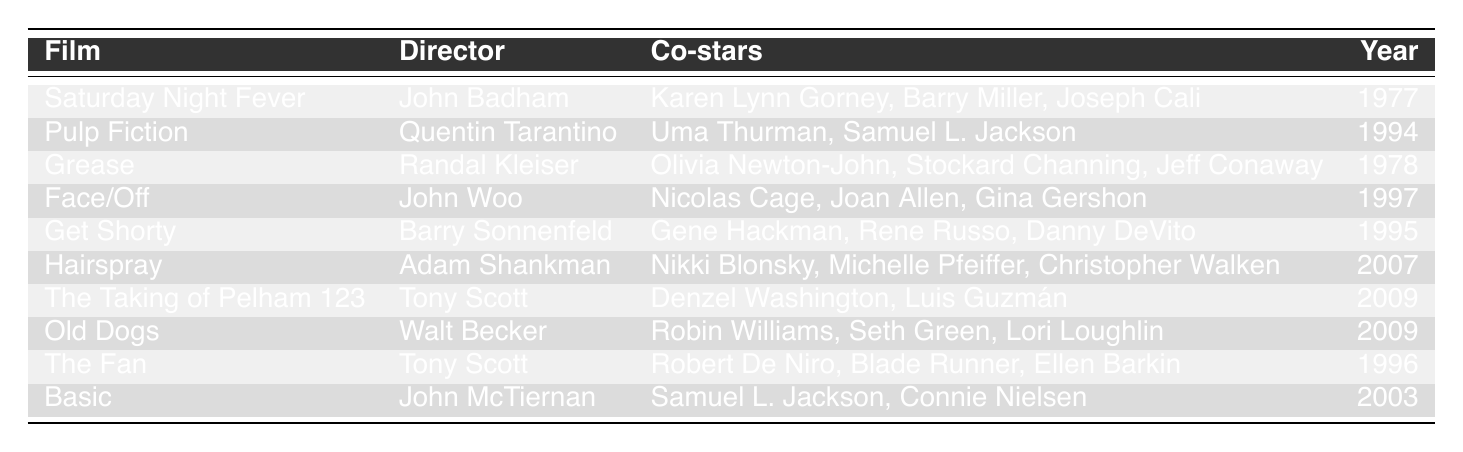What is the earliest film listed in the table? The table lists films alongside their release years. "Saturday Night Fever" is listed with the year 1977, which is the earliest year in the table.
Answer: Saturday Night Fever How many films did John Travolta collaborate on with Tony Scott? The table shows that John Travolta worked with Tony Scott on "The Taking of Pelham 123" and "The Fan," which makes a total of two films.
Answer: 2 Which film features Uma Thurman as a co-star? Referring to the "Co-stars" column, "Pulp Fiction" lists Uma Thurman as a co-star, which answers the question directly.
Answer: Pulp Fiction Which director worked with John Travolta on the most number of films in this list? Tony Scott directed two films ("The Taking of Pelham 123" and "The Fan") with John Travolta, which is the highest compared to other directors in the table.
Answer: Tony Scott Did John Travolta act in any film released in 2009? The table displays two films released in 2009: "The Taking of Pelham 123" and "Old Dogs." John Travolta starred in "The Taking of Pelham 123," confirming he acted in a film from that year.
Answer: Yes What is the total number of films listed in the table? By counting the entries in the first column, there are 10 films listed in the table.
Answer: 10 Which co-star appeared with John Travolta in the most films according to the table? Analyzing the "Co-stars" column for films with Travolta, Samuel L. Jackson appeared in both "Pulp Fiction" and "Basic." Therefore, he is the only co-star appearing in multiple films with John Travolta in this list.
Answer: Samuel L. Jackson In which film did John Travolta star alongside Denzel Washington? From the table, "The Taking of Pelham 123" is identified as the film featuring both John Travolta and Denzel Washington, answering the question.
Answer: The Taking of Pelham 123 What is the relationship between the release year and the title of the film “Hairspray”? "Hairspray" is released in 2007. This information is found in the table aligning the release year with the film title directly.
Answer: 2007 Which film features the latest collaboration with John Travolta according to the table? The most recent year listed in the table is 2009, corresponding to "The Taking of Pelham 123" and "Old Dogs." Either can be accepted as the latest collaboration.
Answer: The Taking of Pelham 123 or Old Dogs 